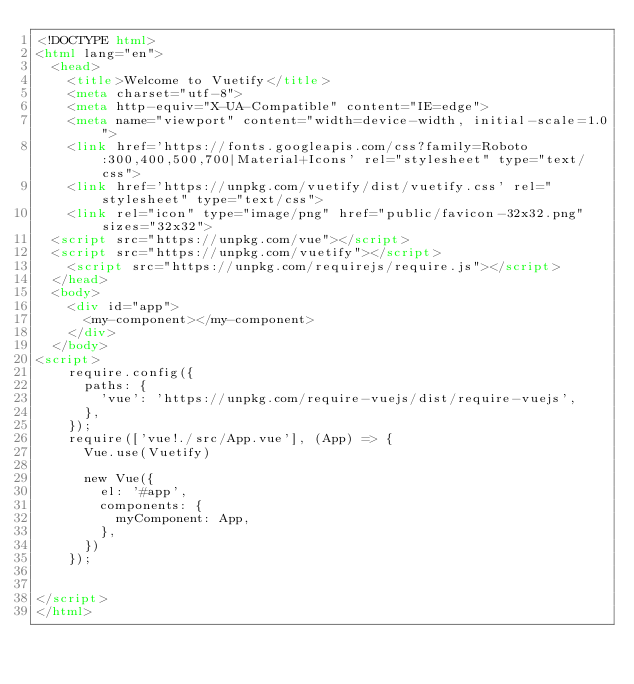Convert code to text. <code><loc_0><loc_0><loc_500><loc_500><_HTML_><!DOCTYPE html>
<html lang="en">
  <head>
    <title>Welcome to Vuetify</title>
    <meta charset="utf-8">
    <meta http-equiv="X-UA-Compatible" content="IE=edge">
    <meta name="viewport" content="width=device-width, initial-scale=1.0">
    <link href='https://fonts.googleapis.com/css?family=Roboto:300,400,500,700|Material+Icons' rel="stylesheet" type="text/css">
    <link href='https://unpkg.com/vuetify/dist/vuetify.css' rel="stylesheet" type="text/css">
    <link rel="icon" type="image/png" href="public/favicon-32x32.png" sizes="32x32">
  <script src="https://unpkg.com/vue"></script>
  <script src="https://unpkg.com/vuetify"></script>
    <script src="https://unpkg.com/requirejs/require.js"></script>
  </head>
  <body>
    <div id="app">
      <my-component></my-component>
    </div>
  </body>
<script>
    require.config({
      paths: {
        'vue': 'https://unpkg.com/require-vuejs/dist/require-vuejs',
      },
    });
    require(['vue!./src/App.vue'], (App) => {
      Vue.use(Vuetify)

      new Vue({
        el: '#app',
        components: {
          myComponent: App,
        },
      })
    });

  
</script>
</html>
</code> 